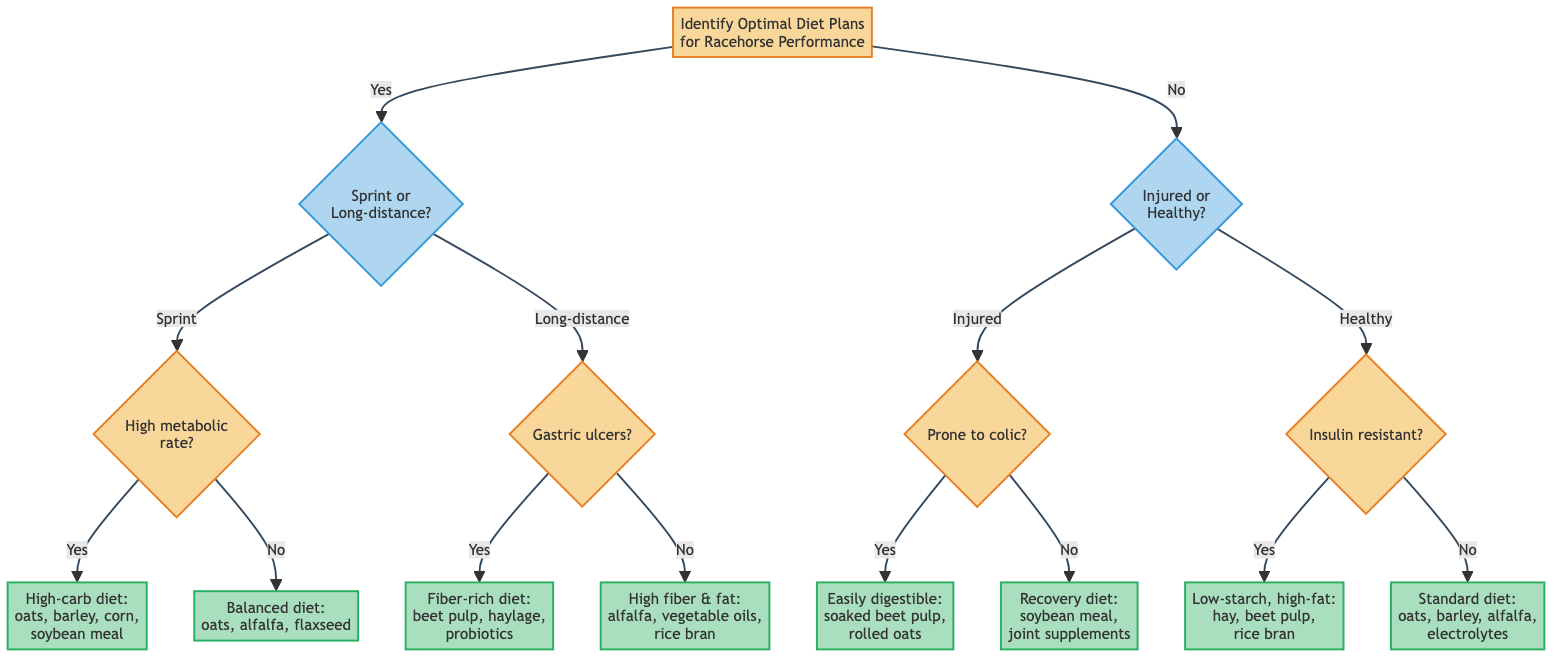What are the two main conditions used to determine the diet plan? The two main conditions featured in the diagram are whether the horse is in training for sprints or long-distance races, and whether the horse is currently injured or healthy. These conditions guide the decision-making process for determining the optimal diet.
Answer: Sprints/Long-distance and Injured/Healthy How many recommendations are made for sprints? There are two recommendations made for sprints based on the horse's metabolic rate: a high-carbohydrate diet if high metabolic rate and a balanced diet if not. Each path of the decision tree provides a specific recommendation.
Answer: 2 What diet should be recommended if the horse has gastric ulcers? For horses with gastric ulcers, the diagram recommends a fiber-rich diet with beet pulp and haylage, minimal grains to reduce ulcer risk, supplemented with probiotics. This recommendation stem from the particular decision path outlined in the diagram.
Answer: Fiber-rich diet with beet pulp and haylage, minimal grains, probiotics What is the recommendation if the horse is healthy and insulin resistant? The recommendation for a healthy horse that is also insulin resistant is a low-starch, high-fat diet including hay, beet pulp, and stabilized rice bran, supplemented with chromium and magnesium. Following the diagram, this outcome is reached through specific decision paths.
Answer: Low-starch, high-fat diet with hay, beet pulp, rice bran How does the diagram differentiate diets for injured horses? The diagram differentiates diets for injured horses based on whether they are prone to colic during recovery. If they are prone to colic, the recommendation is for easily digestible feeds; otherwise, a recovery diet with high-quality protein sources is recommended. This process illustrates the different needs based on the horse's recovery status.
Answer: Based on colic propensity What is the output if the horse is healthy with no signs of insulin resistance? If the horse is healthy and shows no signs of insulin resistance, the output is the standard training diet, which includes a mix of oats, barley, and alfalfa, supplemented with electrolytes and vitamins. The diagram guides this conclusion through a specific flow starting from healthy and no insulin resistance.
Answer: Standard training diet with oats, barley, alfalfa, electrolytes 